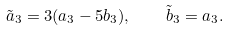Convert formula to latex. <formula><loc_0><loc_0><loc_500><loc_500>\tilde { a } _ { 3 } = 3 ( a _ { 3 } - 5 b _ { 3 } ) , \quad \tilde { b } _ { 3 } = a _ { 3 } .</formula> 